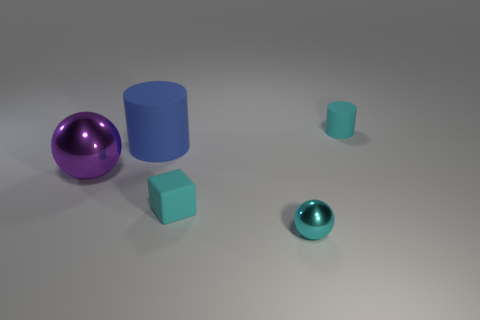What materials do the objects in the image seem to be made of? The objects in the image appear to be made of various materials. The large purple sphere and tiny cyan sphere have reflective surfaces indicating they could be composed of polished metal or plastic. The cyan cube seems to be made of rubber due to its matte finish, and the two cylinders look like they could be either painted wood or matte plastic. 